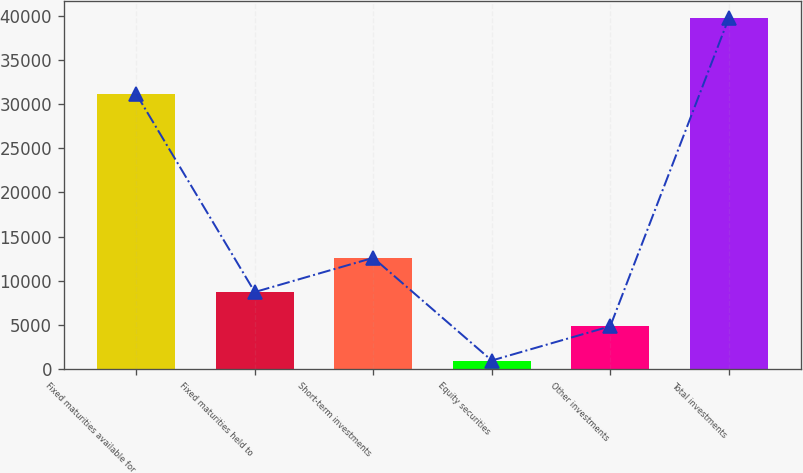<chart> <loc_0><loc_0><loc_500><loc_500><bar_chart><fcel>Fixed maturities available for<fcel>Fixed maturities held to<fcel>Short-term investments<fcel>Equity securities<fcel>Other investments<fcel>Total investments<nl><fcel>31155<fcel>8734.4<fcel>12607.6<fcel>988<fcel>4861.2<fcel>39720<nl></chart> 